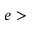<formula> <loc_0><loc_0><loc_500><loc_500>e ></formula> 